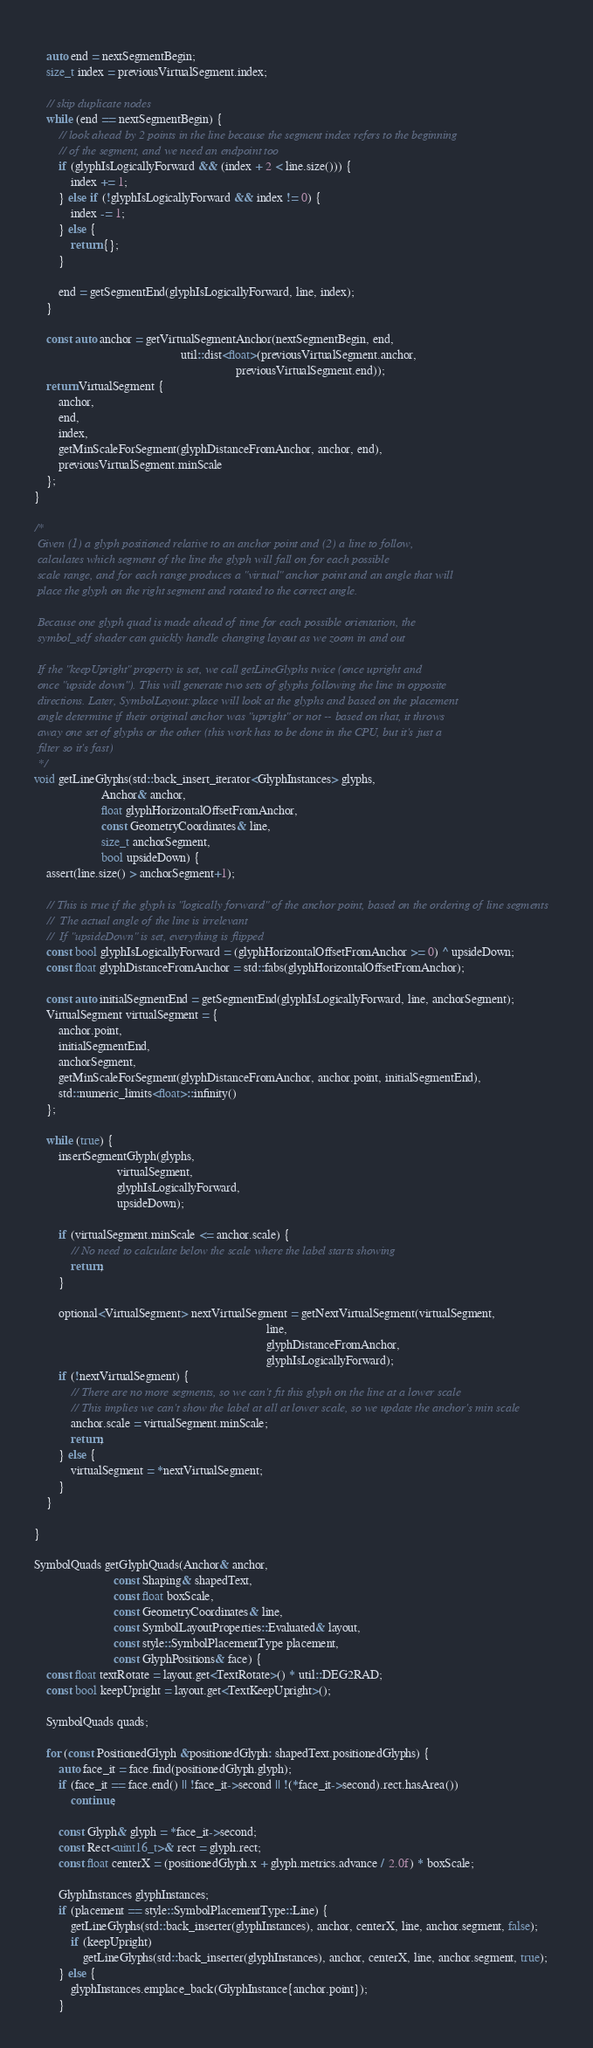Convert code to text. <code><loc_0><loc_0><loc_500><loc_500><_C++_>    
    auto end = nextSegmentBegin;
    size_t index = previousVirtualSegment.index;

    // skip duplicate nodes
    while (end == nextSegmentBegin) {
        // look ahead by 2 points in the line because the segment index refers to the beginning
        // of the segment, and we need an endpoint too
        if (glyphIsLogicallyForward && (index + 2 < line.size())) {
            index += 1;
        } else if (!glyphIsLogicallyForward && index != 0) {
            index -= 1;
        } else {
            return {};
        }
        
        end = getSegmentEnd(glyphIsLogicallyForward, line, index);
    }
    
    const auto anchor = getVirtualSegmentAnchor(nextSegmentBegin, end,
                                                util::dist<float>(previousVirtualSegment.anchor,
                                                                  previousVirtualSegment.end));
    return VirtualSegment {
        anchor,
        end,
        index,
        getMinScaleForSegment(glyphDistanceFromAnchor, anchor, end),
        previousVirtualSegment.minScale
    };
}
    
/*
 Given (1) a glyph positioned relative to an anchor point and (2) a line to follow,
 calculates which segment of the line the glyph will fall on for each possible
 scale range, and for each range produces a "virtual" anchor point and an angle that will
 place the glyph on the right segment and rotated to the correct angle.
 
 Because one glyph quad is made ahead of time for each possible orientation, the
 symbol_sdf shader can quickly handle changing layout as we zoom in and out
 
 If the "keepUpright" property is set, we call getLineGlyphs twice (once upright and 
 once "upside down"). This will generate two sets of glyphs following the line in opposite
 directions. Later, SymbolLayout::place will look at the glyphs and based on the placement
 angle determine if their original anchor was "upright" or not -- based on that, it throws
 away one set of glyphs or the other (this work has to be done in the CPU, but it's just a
 filter so it's fast)
 */
void getLineGlyphs(std::back_insert_iterator<GlyphInstances> glyphs,
                      Anchor& anchor,
                      float glyphHorizontalOffsetFromAnchor,
                      const GeometryCoordinates& line,
                      size_t anchorSegment,
                      bool upsideDown) {
    assert(line.size() > anchorSegment+1);
    
    // This is true if the glyph is "logically forward" of the anchor point, based on the ordering of line segments
    //  The actual angle of the line is irrelevant
    //  If "upsideDown" is set, everything is flipped
    const bool glyphIsLogicallyForward = (glyphHorizontalOffsetFromAnchor >= 0) ^ upsideDown;
    const float glyphDistanceFromAnchor = std::fabs(glyphHorizontalOffsetFromAnchor);
    
    const auto initialSegmentEnd = getSegmentEnd(glyphIsLogicallyForward, line, anchorSegment);
    VirtualSegment virtualSegment = {
        anchor.point,
        initialSegmentEnd,
        anchorSegment,
        getMinScaleForSegment(glyphDistanceFromAnchor, anchor.point, initialSegmentEnd),
        std::numeric_limits<float>::infinity()
    };
    
    while (true) {
        insertSegmentGlyph(glyphs,
                           virtualSegment,
                           glyphIsLogicallyForward,
                           upsideDown);
        
        if (virtualSegment.minScale <= anchor.scale) {
            // No need to calculate below the scale where the label starts showing
            return;
        }
        
        optional<VirtualSegment> nextVirtualSegment = getNextVirtualSegment(virtualSegment,
                                                                            line,
                                                                            glyphDistanceFromAnchor,
                                                                            glyphIsLogicallyForward);
        if (!nextVirtualSegment) {
            // There are no more segments, so we can't fit this glyph on the line at a lower scale
            // This implies we can't show the label at all at lower scale, so we update the anchor's min scale
            anchor.scale = virtualSegment.minScale;
            return;
        } else {
            virtualSegment = *nextVirtualSegment;
        }
    }
    
}

SymbolQuads getGlyphQuads(Anchor& anchor,
                          const Shaping& shapedText,
                          const float boxScale,
                          const GeometryCoordinates& line,
                          const SymbolLayoutProperties::Evaluated& layout,
                          const style::SymbolPlacementType placement,
                          const GlyphPositions& face) {
    const float textRotate = layout.get<TextRotate>() * util::DEG2RAD;
    const bool keepUpright = layout.get<TextKeepUpright>();

    SymbolQuads quads;

    for (const PositionedGlyph &positionedGlyph: shapedText.positionedGlyphs) {
        auto face_it = face.find(positionedGlyph.glyph);
        if (face_it == face.end() || !face_it->second || !(*face_it->second).rect.hasArea())
            continue;

        const Glyph& glyph = *face_it->second;
        const Rect<uint16_t>& rect = glyph.rect;
        const float centerX = (positionedGlyph.x + glyph.metrics.advance / 2.0f) * boxScale;

        GlyphInstances glyphInstances;
        if (placement == style::SymbolPlacementType::Line) {
            getLineGlyphs(std::back_inserter(glyphInstances), anchor, centerX, line, anchor.segment, false);
            if (keepUpright)
                getLineGlyphs(std::back_inserter(glyphInstances), anchor, centerX, line, anchor.segment, true);
        } else {
            glyphInstances.emplace_back(GlyphInstance{anchor.point});
        }
</code> 